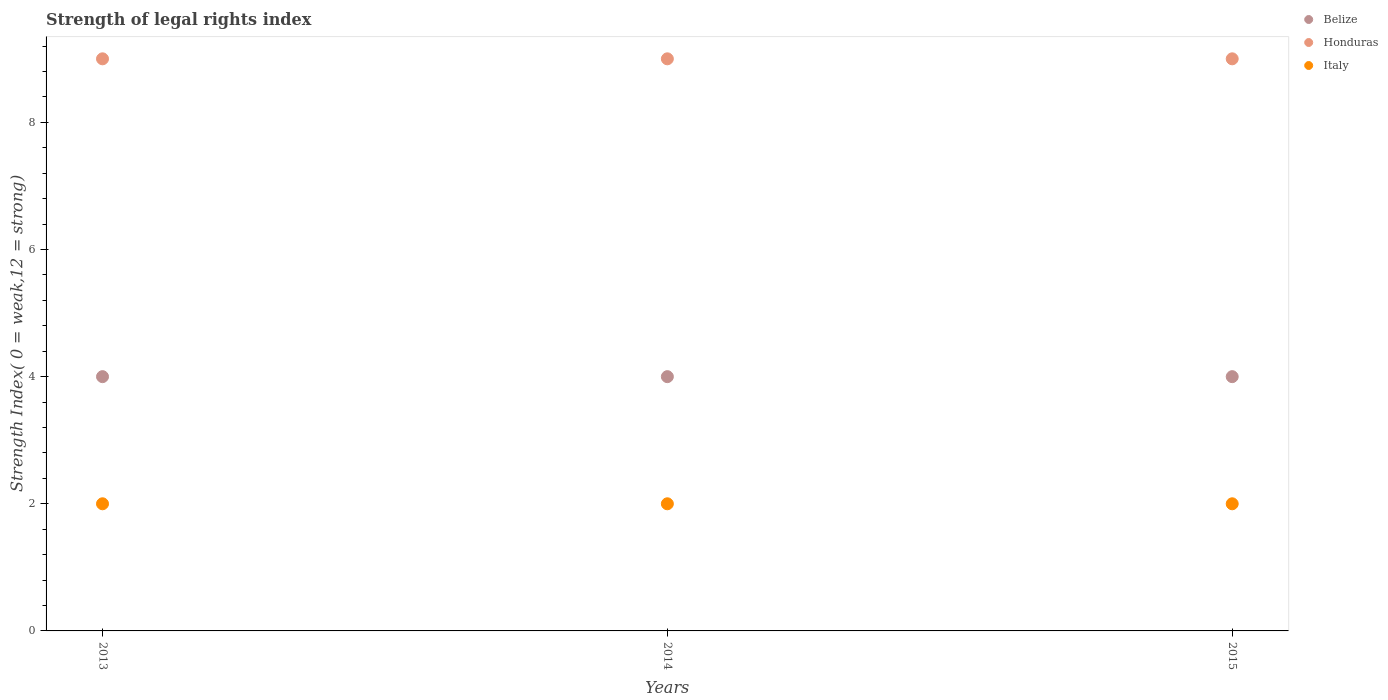How many different coloured dotlines are there?
Your response must be concise. 3. Is the number of dotlines equal to the number of legend labels?
Make the answer very short. Yes. What is the strength index in Italy in 2013?
Offer a terse response. 2. Across all years, what is the maximum strength index in Belize?
Offer a very short reply. 4. Across all years, what is the minimum strength index in Belize?
Give a very brief answer. 4. In which year was the strength index in Honduras minimum?
Keep it short and to the point. 2013. What is the difference between the strength index in Belize in 2015 and the strength index in Italy in 2014?
Provide a short and direct response. 2. In the year 2014, what is the difference between the strength index in Italy and strength index in Honduras?
Provide a succinct answer. -7. In how many years, is the strength index in Belize greater than 0.8?
Your answer should be very brief. 3. Is the strength index in Italy in 2014 less than that in 2015?
Make the answer very short. No. Is the difference between the strength index in Italy in 2013 and 2015 greater than the difference between the strength index in Honduras in 2013 and 2015?
Your response must be concise. No. Is it the case that in every year, the sum of the strength index in Honduras and strength index in Italy  is greater than the strength index in Belize?
Offer a very short reply. Yes. Does the strength index in Italy monotonically increase over the years?
Your answer should be compact. No. Is the strength index in Honduras strictly greater than the strength index in Italy over the years?
Keep it short and to the point. Yes. Is the strength index in Belize strictly less than the strength index in Italy over the years?
Provide a short and direct response. No. How many dotlines are there?
Offer a very short reply. 3. How many years are there in the graph?
Give a very brief answer. 3. What is the difference between two consecutive major ticks on the Y-axis?
Ensure brevity in your answer.  2. Does the graph contain grids?
Your response must be concise. No. Where does the legend appear in the graph?
Provide a succinct answer. Top right. How many legend labels are there?
Your answer should be compact. 3. How are the legend labels stacked?
Your response must be concise. Vertical. What is the title of the graph?
Offer a very short reply. Strength of legal rights index. Does "Heavily indebted poor countries" appear as one of the legend labels in the graph?
Make the answer very short. No. What is the label or title of the Y-axis?
Your answer should be very brief. Strength Index( 0 = weak,12 = strong). What is the Strength Index( 0 = weak,12 = strong) of Honduras in 2013?
Offer a terse response. 9. What is the Strength Index( 0 = weak,12 = strong) in Italy in 2013?
Your answer should be very brief. 2. What is the Strength Index( 0 = weak,12 = strong) of Italy in 2014?
Offer a terse response. 2. What is the Strength Index( 0 = weak,12 = strong) of Honduras in 2015?
Your answer should be very brief. 9. What is the Strength Index( 0 = weak,12 = strong) in Italy in 2015?
Ensure brevity in your answer.  2. Across all years, what is the maximum Strength Index( 0 = weak,12 = strong) in Belize?
Your answer should be compact. 4. Across all years, what is the minimum Strength Index( 0 = weak,12 = strong) in Belize?
Your response must be concise. 4. Across all years, what is the minimum Strength Index( 0 = weak,12 = strong) in Honduras?
Make the answer very short. 9. Across all years, what is the minimum Strength Index( 0 = weak,12 = strong) of Italy?
Offer a terse response. 2. What is the difference between the Strength Index( 0 = weak,12 = strong) of Italy in 2013 and that in 2014?
Ensure brevity in your answer.  0. What is the difference between the Strength Index( 0 = weak,12 = strong) in Belize in 2013 and that in 2015?
Your response must be concise. 0. What is the difference between the Strength Index( 0 = weak,12 = strong) of Belize in 2013 and the Strength Index( 0 = weak,12 = strong) of Honduras in 2014?
Provide a short and direct response. -5. What is the difference between the Strength Index( 0 = weak,12 = strong) of Honduras in 2013 and the Strength Index( 0 = weak,12 = strong) of Italy in 2014?
Ensure brevity in your answer.  7. What is the difference between the Strength Index( 0 = weak,12 = strong) in Belize in 2013 and the Strength Index( 0 = weak,12 = strong) in Honduras in 2015?
Make the answer very short. -5. What is the difference between the Strength Index( 0 = weak,12 = strong) of Honduras in 2013 and the Strength Index( 0 = weak,12 = strong) of Italy in 2015?
Your answer should be compact. 7. What is the average Strength Index( 0 = weak,12 = strong) of Belize per year?
Offer a very short reply. 4. In the year 2013, what is the difference between the Strength Index( 0 = weak,12 = strong) in Belize and Strength Index( 0 = weak,12 = strong) in Honduras?
Offer a terse response. -5. In the year 2013, what is the difference between the Strength Index( 0 = weak,12 = strong) of Belize and Strength Index( 0 = weak,12 = strong) of Italy?
Your response must be concise. 2. In the year 2013, what is the difference between the Strength Index( 0 = weak,12 = strong) of Honduras and Strength Index( 0 = weak,12 = strong) of Italy?
Provide a succinct answer. 7. In the year 2014, what is the difference between the Strength Index( 0 = weak,12 = strong) in Belize and Strength Index( 0 = weak,12 = strong) in Italy?
Keep it short and to the point. 2. In the year 2015, what is the difference between the Strength Index( 0 = weak,12 = strong) of Belize and Strength Index( 0 = weak,12 = strong) of Honduras?
Your answer should be compact. -5. In the year 2015, what is the difference between the Strength Index( 0 = weak,12 = strong) of Belize and Strength Index( 0 = weak,12 = strong) of Italy?
Keep it short and to the point. 2. In the year 2015, what is the difference between the Strength Index( 0 = weak,12 = strong) in Honduras and Strength Index( 0 = weak,12 = strong) in Italy?
Make the answer very short. 7. What is the ratio of the Strength Index( 0 = weak,12 = strong) in Belize in 2013 to that in 2014?
Your response must be concise. 1. What is the ratio of the Strength Index( 0 = weak,12 = strong) of Honduras in 2013 to that in 2014?
Ensure brevity in your answer.  1. What is the ratio of the Strength Index( 0 = weak,12 = strong) of Belize in 2013 to that in 2015?
Provide a succinct answer. 1. What is the ratio of the Strength Index( 0 = weak,12 = strong) in Belize in 2014 to that in 2015?
Offer a terse response. 1. What is the ratio of the Strength Index( 0 = weak,12 = strong) in Honduras in 2014 to that in 2015?
Your answer should be very brief. 1. What is the difference between the highest and the second highest Strength Index( 0 = weak,12 = strong) of Honduras?
Offer a terse response. 0. 